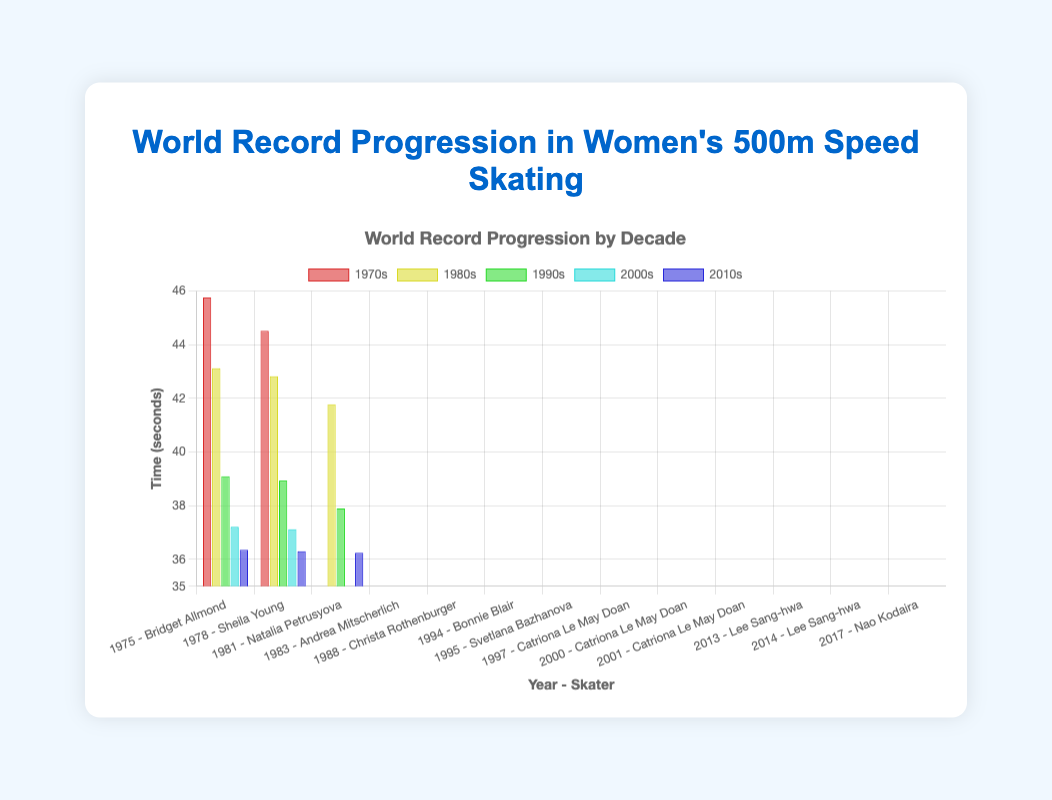What's the average world record time in the 2010s? First, list the record times in the 2010s: 36.36, 36.31, and 36.25. Sum these times: 36.36 + 36.31 + 36.25 = 108.92. Then divide by the number of records (3): 108.92 / 3 = 36.3067 seconds.
Answer: 36.31 Which decade showed the most significant improvement in the world record times? By comparing initial and final times in each decade: 1970s (45.76 to 44.52 - difference 1.24), 1980s (43.13 to 41.78 - difference 1.35), 1990s (39.10 to 37.90 - difference 1.20), 2000s (37.22 to 37.13 - difference 0.09), 2010s (36.36 to 36.25 - difference 0.11). The 1980s had the most significant improvement of 1.35 seconds.
Answer: 1980s How many times did Lee Sang-hwa set a new world record? Identify the records set by Lee Sang-hwa in the 2010s: 2013 (36.36) and 2014 (36.31), making it twice.
Answer: 2 What is the difference in seconds between the world record times set in 2001 and 2017? Compare the times of 2001 (37.13) and 2017 (36.25): 37.13 - 36.25 = 0.88 seconds.
Answer: 0.88 Who set the world record time in 1997, and what was the time? Look at the record for 1997: Skater - Catriona Le May Doan, Time - 37.90 seconds.
Answer: Catriona Le May Doan, 37.90 What is the shortest recorded time and who achieved it? Identify the shortest time on the chart, which is 36.25 seconds, set by Nao Kodaira in 2017.
Answer: Nao Kodaira Which decade had the highest starting world record time and what was it? The initial records for each decade are: 1970s (45.76), 1980s (43.13), 1990s (39.10), 2000s (37.22), 2010s (36.36). The 1970s had the highest starting record time of 45.76 seconds.
Answer: 1970s, 45.76 How many unique skaters set world records in the 1980s? Identify skaters in the 1980s: Natalia Petrusyova, Andrea Mitscherlich, and Christa Rothenburger. There are 3 unique skaters.
Answer: 3 Compare the world record times for Catriona Le May Doan in 2000 and Lee Sang-hwa in 2014. Who had the faster time? Compare 2000 (37.22) and 2014 (36.31): Lee Sang-hwa in 2014 had the faster time.
Answer: Lee Sang-hwa 